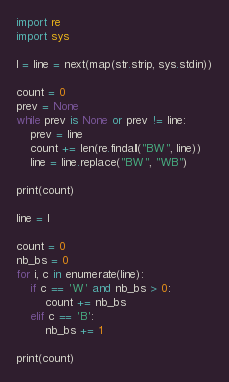<code> <loc_0><loc_0><loc_500><loc_500><_Python_>import re
import sys

l = line = next(map(str.strip, sys.stdin))

count = 0
prev = None
while prev is None or prev != line:
    prev = line
    count += len(re.findall("BW", line))
    line = line.replace("BW", "WB")

print(count)

line = l

count = 0
nb_bs = 0
for i, c in enumerate(line):
    if c == 'W' and nb_bs > 0:
        count += nb_bs
    elif c == 'B':
        nb_bs += 1

print(count)
</code> 